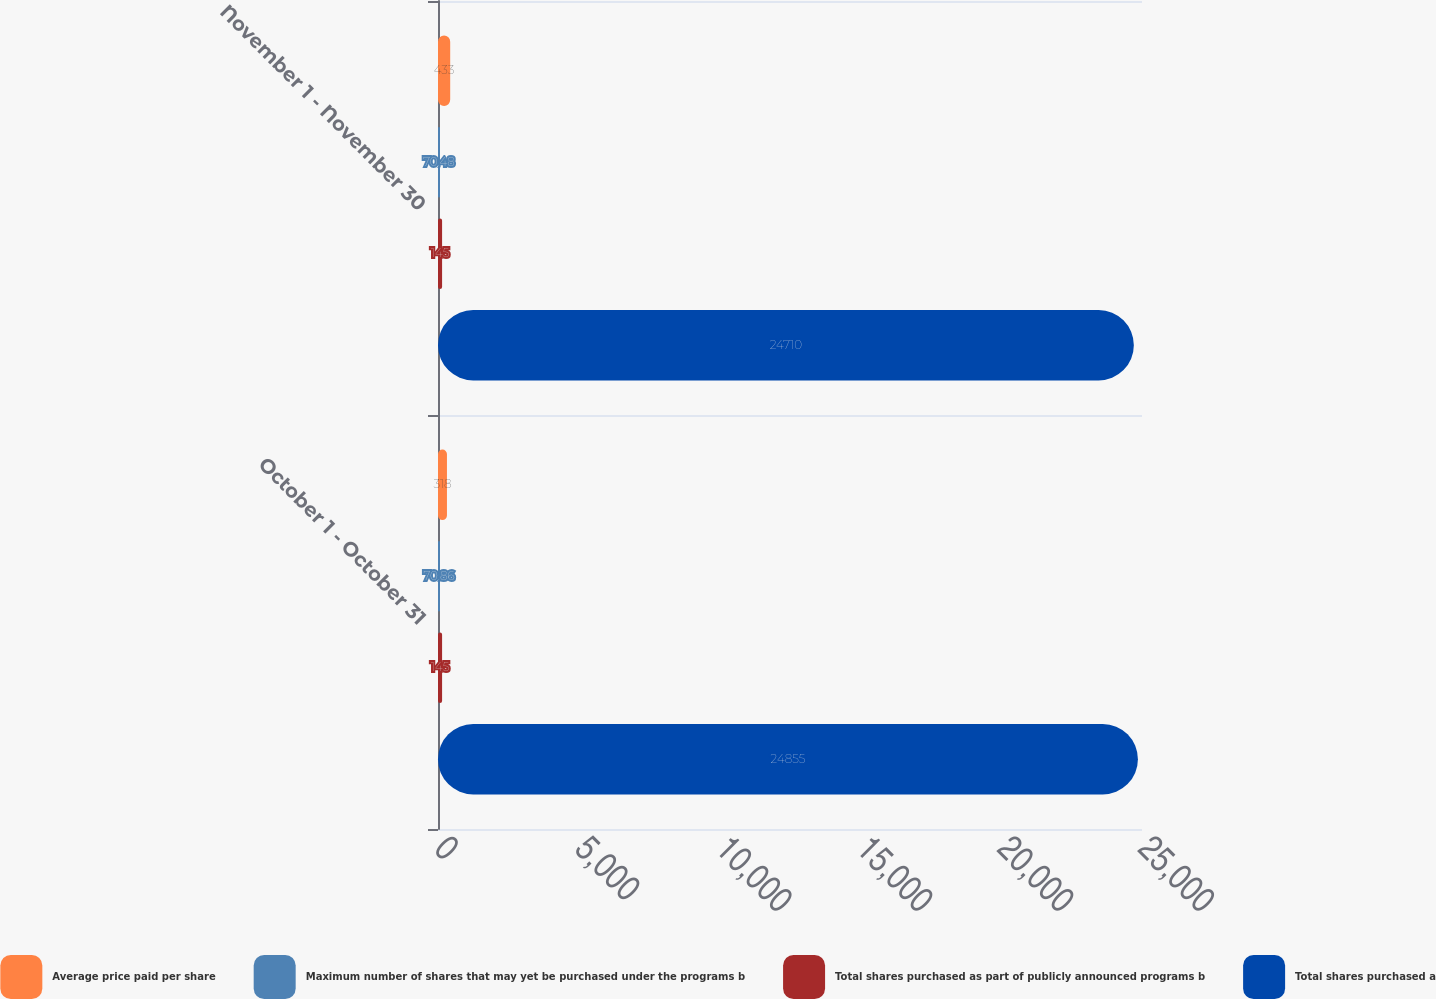<chart> <loc_0><loc_0><loc_500><loc_500><stacked_bar_chart><ecel><fcel>October 1 - October 31<fcel>November 1 - November 30<nl><fcel>Average price paid per share<fcel>318<fcel>433<nl><fcel>Maximum number of shares that may yet be purchased under the programs b<fcel>70.86<fcel>70.48<nl><fcel>Total shares purchased as part of publicly announced programs b<fcel>145<fcel>145<nl><fcel>Total shares purchased a<fcel>24855<fcel>24710<nl></chart> 